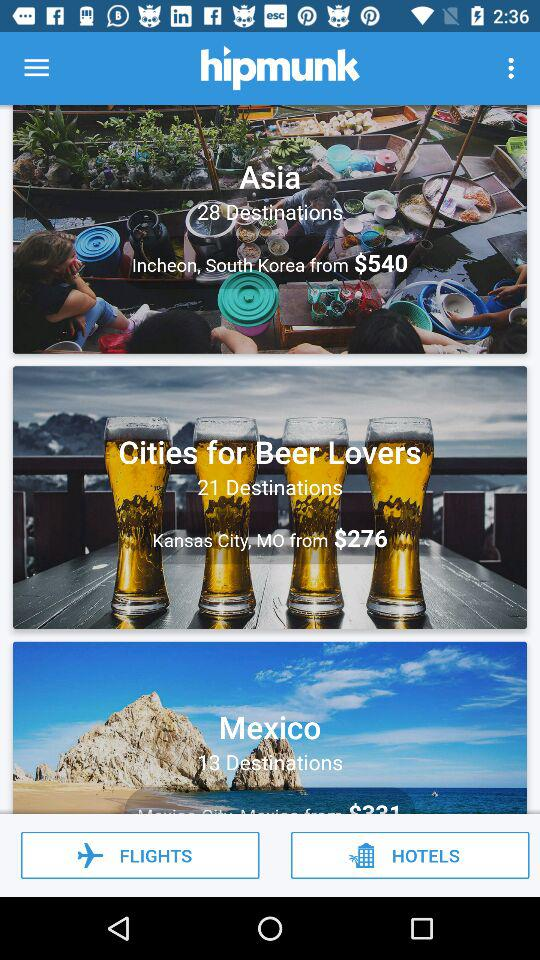What is the price of the Incheon, South Korea trip in Asia? The price of the Incheon, South Korea trip in Asia starts from $540. 